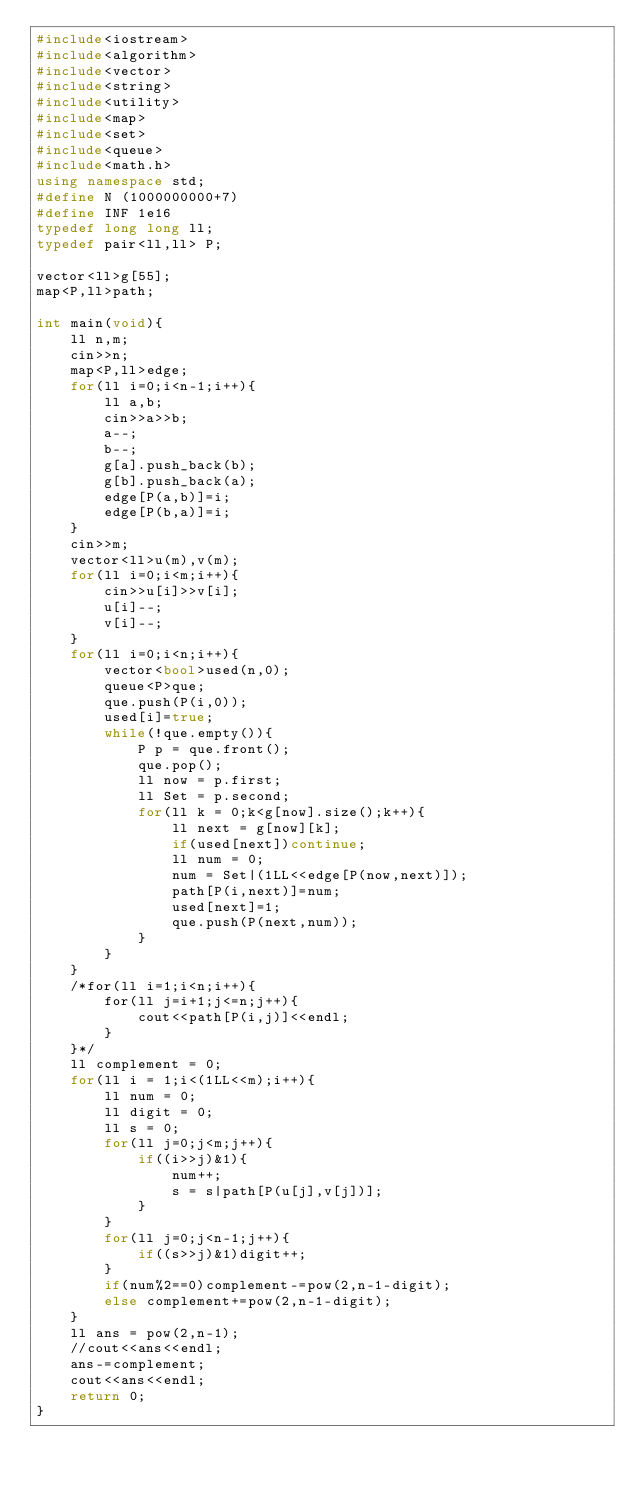Convert code to text. <code><loc_0><loc_0><loc_500><loc_500><_C++_>#include<iostream>
#include<algorithm>
#include<vector>
#include<string>
#include<utility>
#include<map>
#include<set>
#include<queue>
#include<math.h>
using namespace std;
#define N (1000000000+7)
#define INF 1e16
typedef long long ll;
typedef pair<ll,ll> P;

vector<ll>g[55];
map<P,ll>path;

int main(void){
    ll n,m;
    cin>>n;
    map<P,ll>edge;
    for(ll i=0;i<n-1;i++){
        ll a,b;
        cin>>a>>b;
        a--;
        b--;
        g[a].push_back(b);
        g[b].push_back(a);
        edge[P(a,b)]=i;
        edge[P(b,a)]=i;
    }
    cin>>m;
    vector<ll>u(m),v(m);
    for(ll i=0;i<m;i++){
        cin>>u[i]>>v[i];
        u[i]--;
        v[i]--;
    }
    for(ll i=0;i<n;i++){
        vector<bool>used(n,0);
        queue<P>que;
        que.push(P(i,0));
        used[i]=true;
        while(!que.empty()){
            P p = que.front();
            que.pop();
            ll now = p.first;
            ll Set = p.second;
            for(ll k = 0;k<g[now].size();k++){
                ll next = g[now][k];
                if(used[next])continue;
                ll num = 0;
                num = Set|(1LL<<edge[P(now,next)]);
                path[P(i,next)]=num;
                used[next]=1;
                que.push(P(next,num));
            }
        }
    }
    /*for(ll i=1;i<n;i++){
        for(ll j=i+1;j<=n;j++){
            cout<<path[P(i,j)]<<endl;
        }
    }*/
    ll complement = 0;
    for(ll i = 1;i<(1LL<<m);i++){
        ll num = 0;
        ll digit = 0;
        ll s = 0;
        for(ll j=0;j<m;j++){
            if((i>>j)&1){
                num++;
                s = s|path[P(u[j],v[j])];
            }
        }
        for(ll j=0;j<n-1;j++){
            if((s>>j)&1)digit++;
        }
        if(num%2==0)complement-=pow(2,n-1-digit);
        else complement+=pow(2,n-1-digit);
    }
    ll ans = pow(2,n-1);
    //cout<<ans<<endl;
    ans-=complement;
    cout<<ans<<endl;
    return 0;
}</code> 